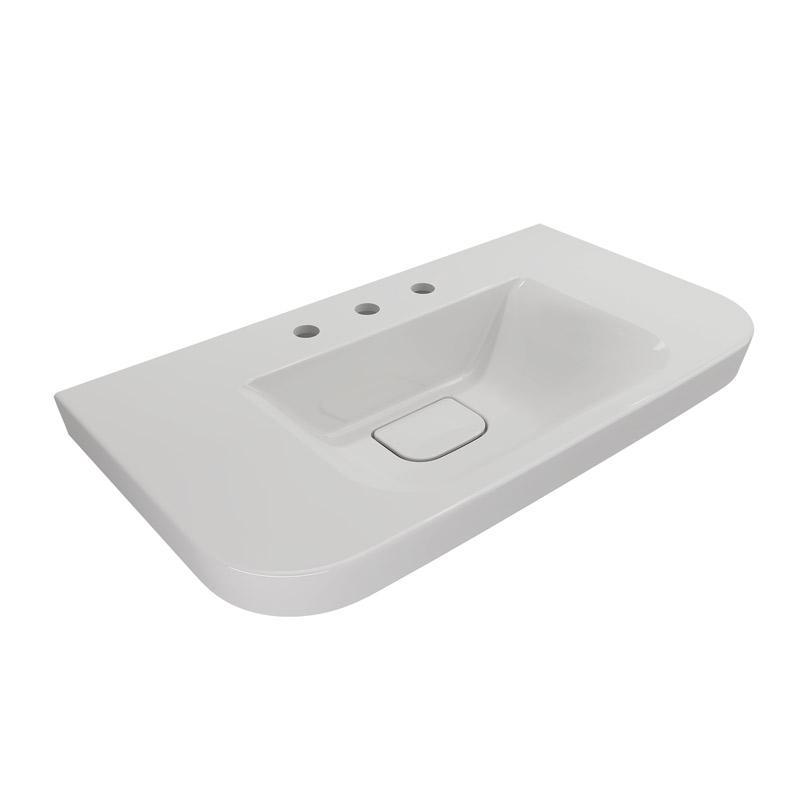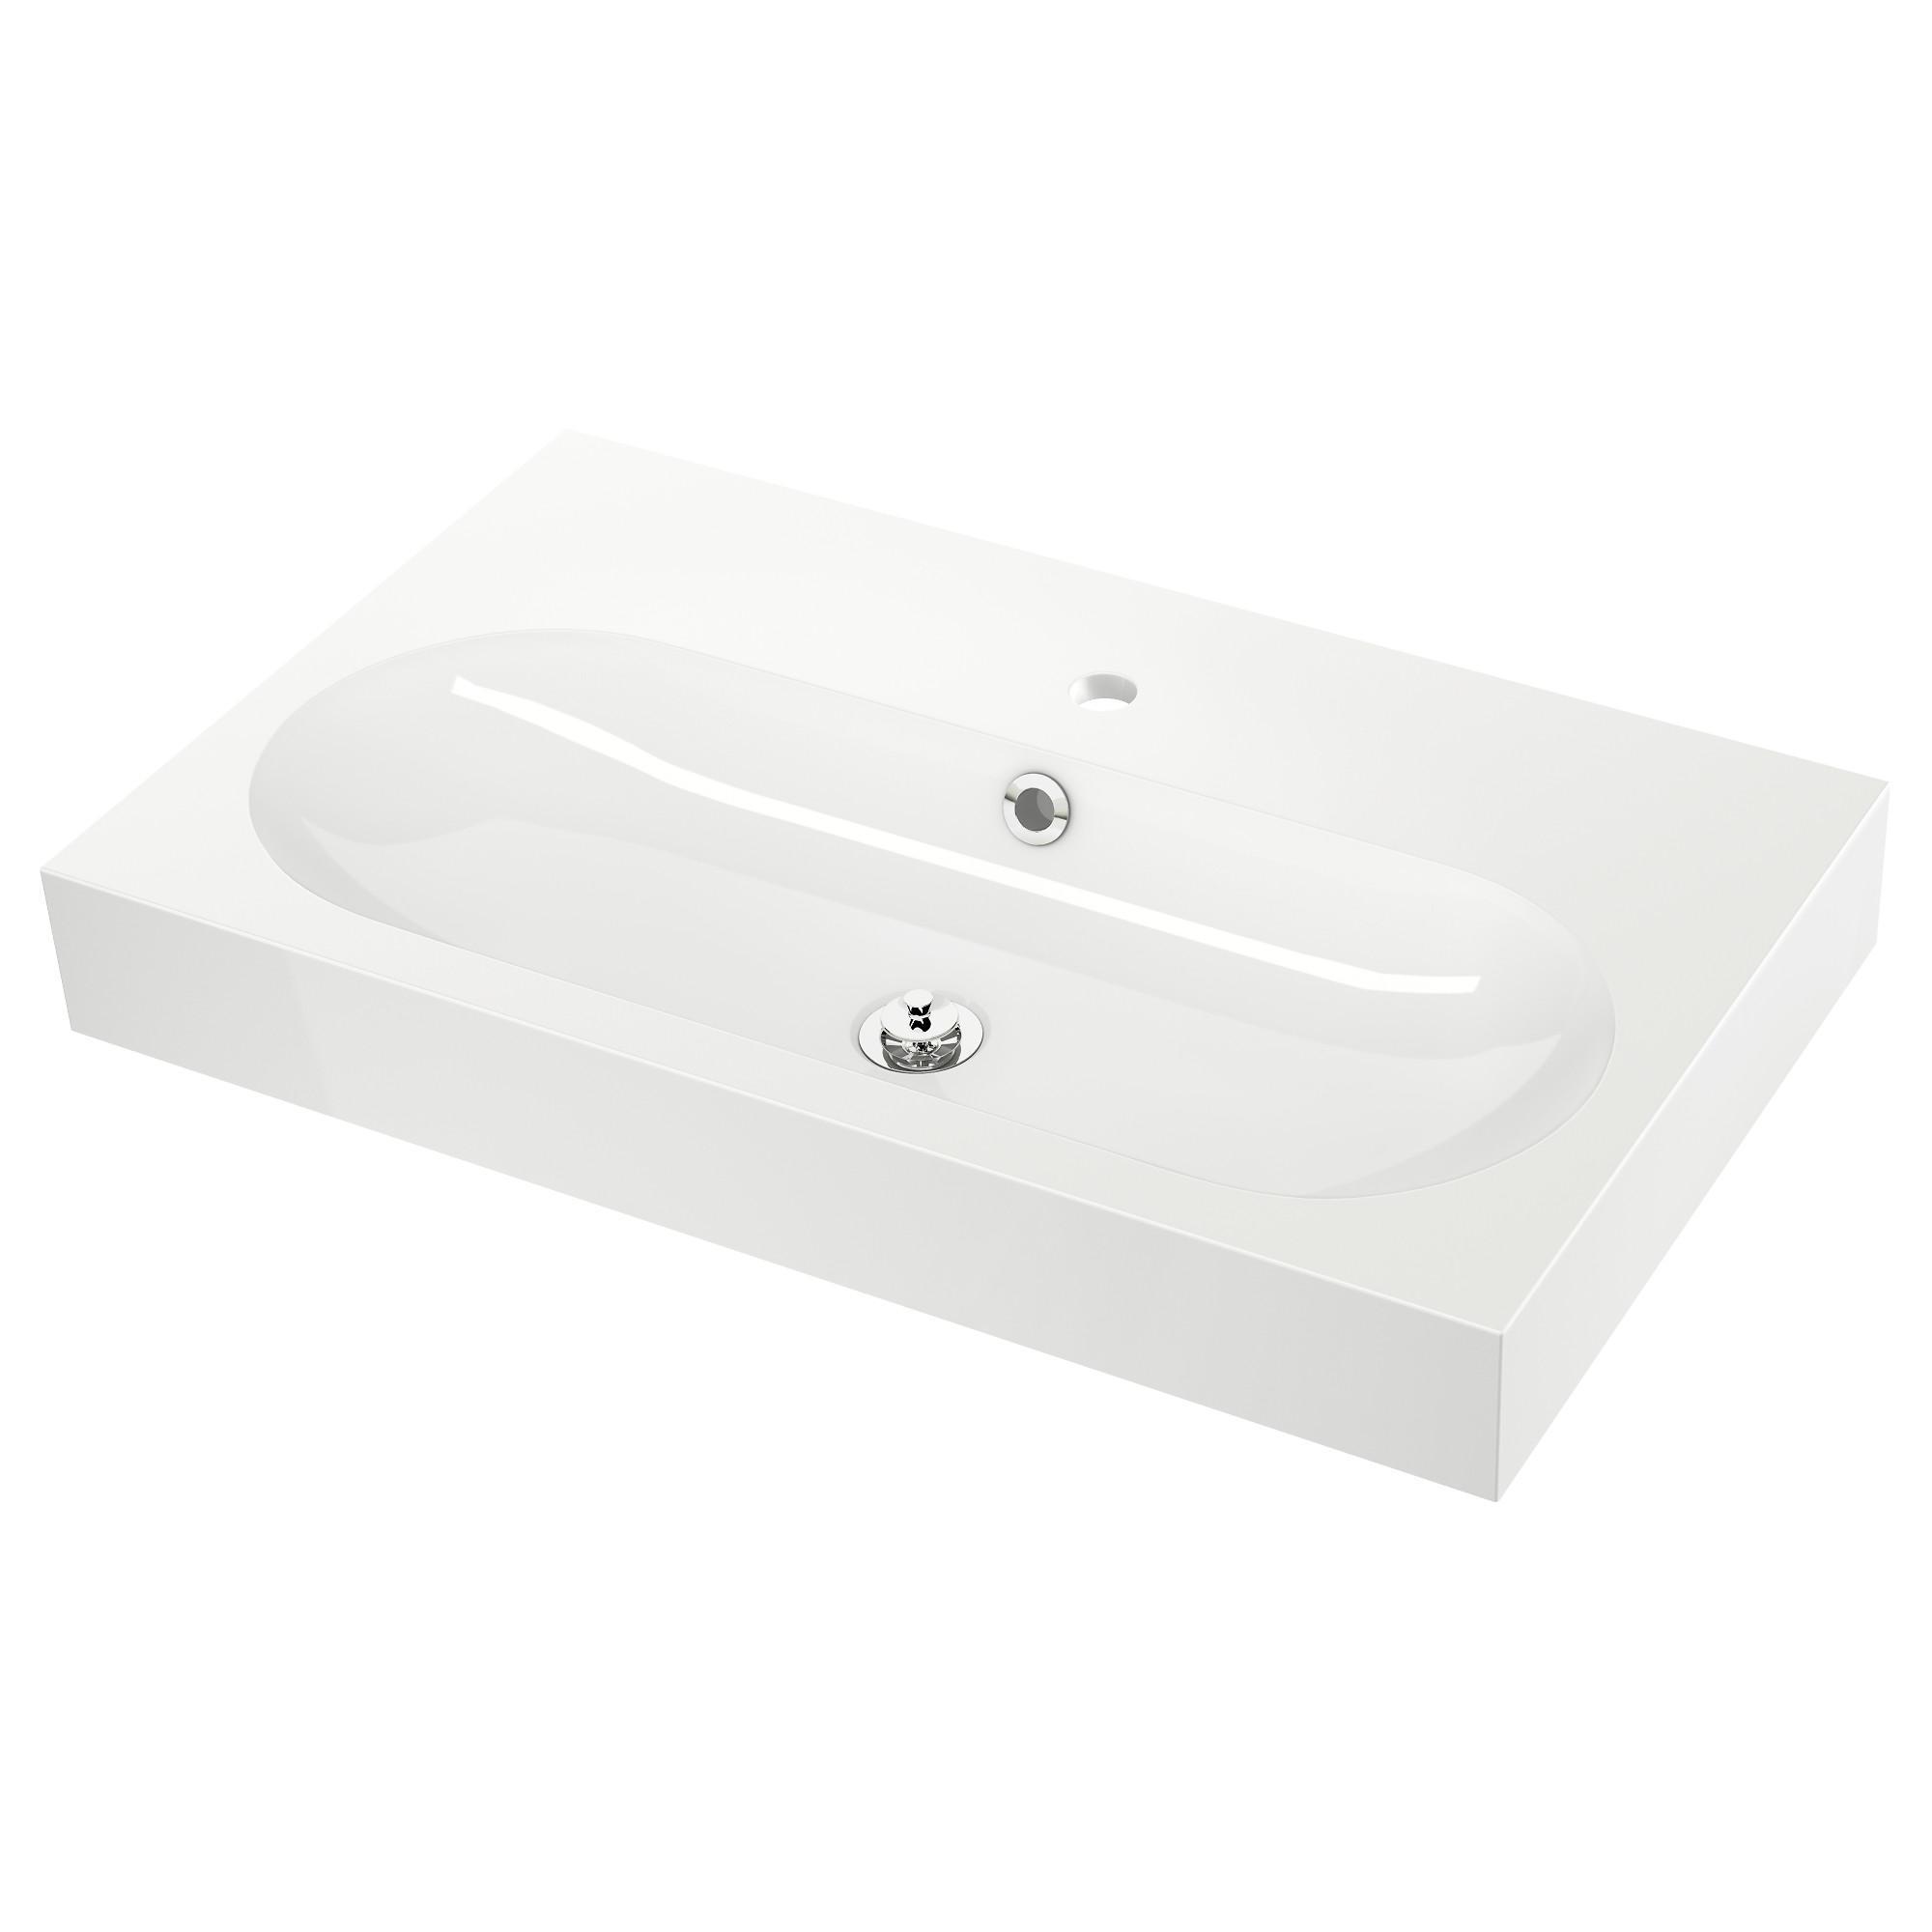The first image is the image on the left, the second image is the image on the right. Examine the images to the left and right. Is the description "There are two wash basins facing the same direction." accurate? Answer yes or no. No. The first image is the image on the left, the second image is the image on the right. Analyze the images presented: Is the assertion "At least one sink is more oblong than rectangular, and no sink has a faucet or spout installed." valid? Answer yes or no. Yes. 